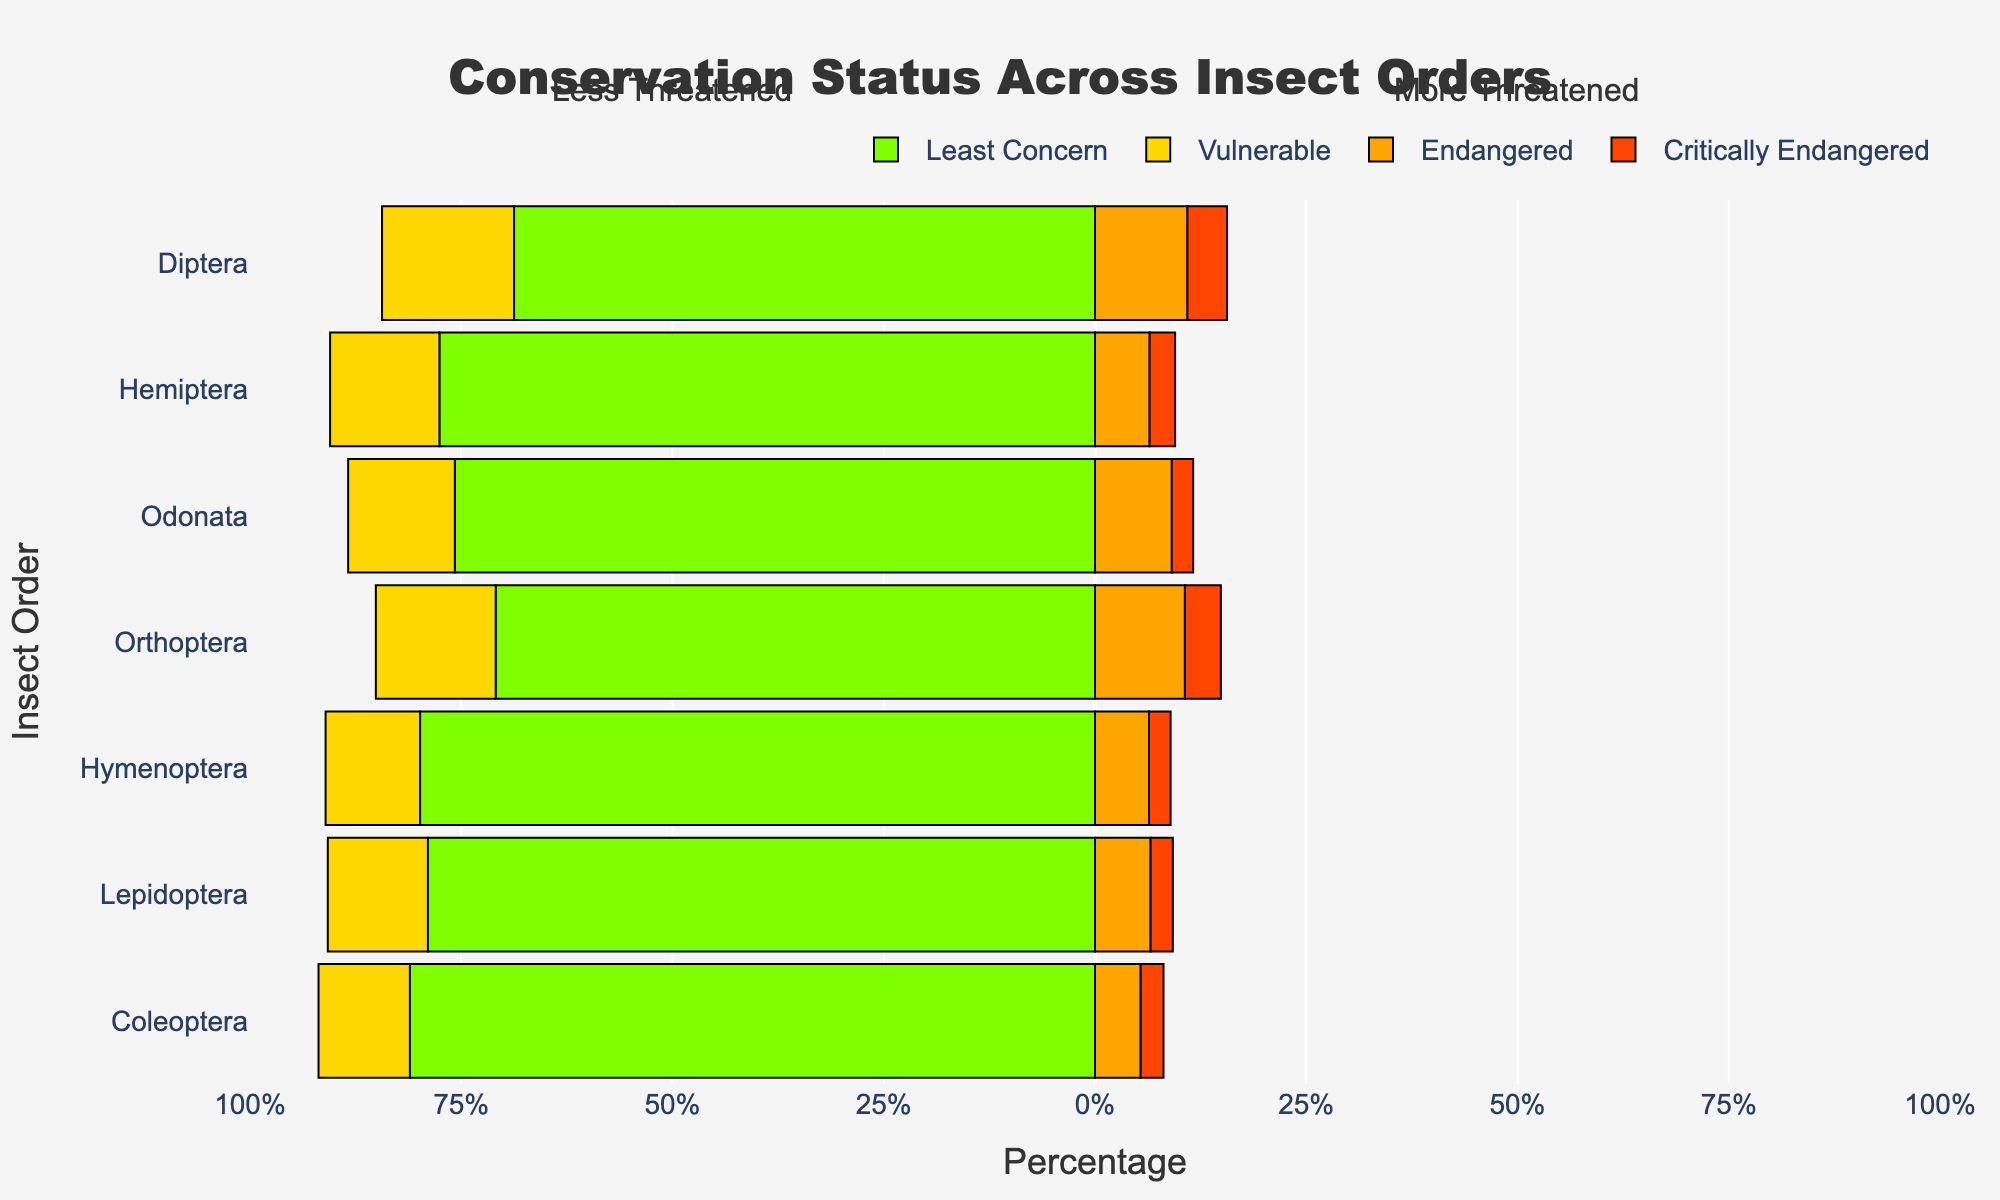Which insect order has the highest percentage of species in the 'Least Concern' category? The figure shows the percentage of species in different conservation status categories for each insect order. The green bars represent the 'Least Concern' category, and the order with the longest green bar indicates the highest percentage.
Answer: Coleoptera What is the sum of 'Endangered' and 'Critically Endangered' percentages for Diptera? To find the sum, locate the orange and red segments for Diptera. Add the percentage of the orange segment (Endangered) and the percentage of the red segment (Critically Endangered).
Answer: 25% Which insect order has a higher percentage of 'Vulnerable' species, Orthoptera or Odonata? Compare the length of the yellow bars for Orthoptera and Odonata. The order with the longer yellow bar has the higher percentage of 'Vulnerable' species.
Answer: Orthoptera What is the difference in the percentage of 'Least Concern' species between Coleoptera and Lepidoptera? Find the green bar lengths for both Coleoptera and Lepidoptera, then subtract the percentage of Lepidoptera from Coleoptera.
Answer: 55.4% Which insect order has the smallest combined percentage of 'Endangered' and 'Critically Endangered' species? Add the percentages of the orange and red bars for each order, and find the order with the smallest combined percentage.
Answer: Hymenoptera Are there more species in the 'Vulnerable' category in Coleoptera or in the 'Critically Endangered' category in Diptera? Compare the length of the yellow bar for Coleoptera with the length of the red bar for Diptera. Determine which bar is longer to identify the category with more species.
Answer: Coleoptera Which insect order has the largest percentage of species in the 'Critically Endangered' category? Look for the tallest red bar in the chart. The insect order corresponding to this bar has the largest percentage of 'Critically Endangered' species.
Answer: Diptera What is the total percentage of 'Vulnerable' species across all insect orders shown? Sum the percentages of the yellow bars for all insect orders.
Answer: 28% 